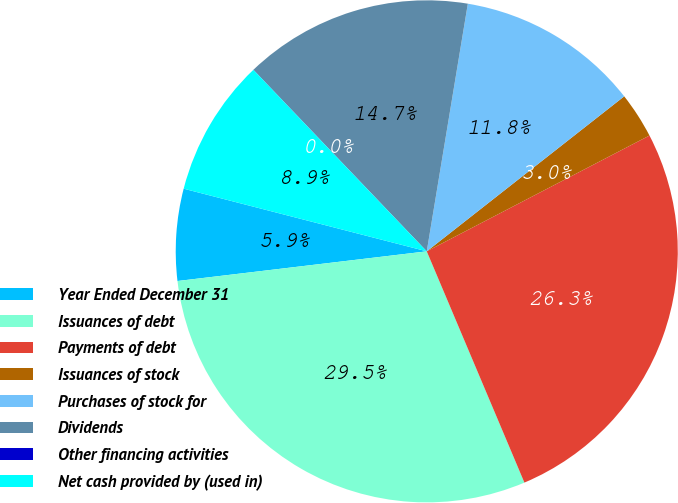Convert chart. <chart><loc_0><loc_0><loc_500><loc_500><pie_chart><fcel>Year Ended December 31<fcel>Issuances of debt<fcel>Payments of debt<fcel>Issuances of stock<fcel>Purchases of stock for<fcel>Dividends<fcel>Other financing activities<fcel>Net cash provided by (used in)<nl><fcel>5.9%<fcel>29.47%<fcel>26.27%<fcel>2.96%<fcel>11.79%<fcel>14.74%<fcel>0.01%<fcel>8.85%<nl></chart> 